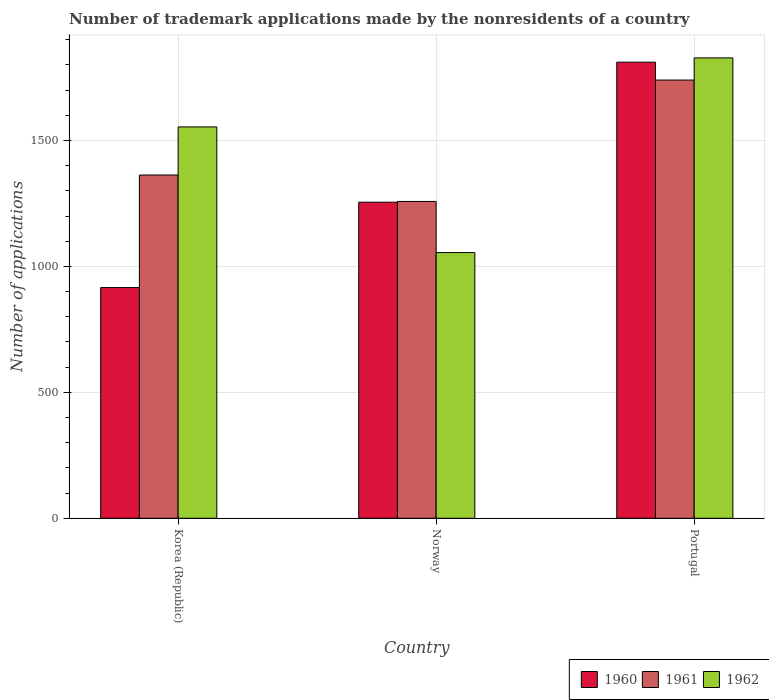How many different coloured bars are there?
Keep it short and to the point. 3. How many groups of bars are there?
Offer a terse response. 3. Are the number of bars per tick equal to the number of legend labels?
Your response must be concise. Yes. Are the number of bars on each tick of the X-axis equal?
Ensure brevity in your answer.  Yes. How many bars are there on the 2nd tick from the left?
Your answer should be very brief. 3. In how many cases, is the number of bars for a given country not equal to the number of legend labels?
Offer a very short reply. 0. What is the number of trademark applications made by the nonresidents in 1960 in Portugal?
Your answer should be very brief. 1811. Across all countries, what is the maximum number of trademark applications made by the nonresidents in 1961?
Offer a terse response. 1740. Across all countries, what is the minimum number of trademark applications made by the nonresidents in 1962?
Make the answer very short. 1055. In which country was the number of trademark applications made by the nonresidents in 1961 maximum?
Provide a succinct answer. Portugal. What is the total number of trademark applications made by the nonresidents in 1961 in the graph?
Your response must be concise. 4361. What is the difference between the number of trademark applications made by the nonresidents in 1960 in Korea (Republic) and that in Portugal?
Your answer should be very brief. -895. What is the difference between the number of trademark applications made by the nonresidents in 1961 in Norway and the number of trademark applications made by the nonresidents in 1960 in Korea (Republic)?
Provide a succinct answer. 342. What is the average number of trademark applications made by the nonresidents in 1960 per country?
Keep it short and to the point. 1327.33. What is the difference between the number of trademark applications made by the nonresidents of/in 1961 and number of trademark applications made by the nonresidents of/in 1962 in Korea (Republic)?
Give a very brief answer. -191. What is the ratio of the number of trademark applications made by the nonresidents in 1961 in Korea (Republic) to that in Norway?
Your response must be concise. 1.08. Is the difference between the number of trademark applications made by the nonresidents in 1961 in Norway and Portugal greater than the difference between the number of trademark applications made by the nonresidents in 1962 in Norway and Portugal?
Provide a short and direct response. Yes. What is the difference between the highest and the second highest number of trademark applications made by the nonresidents in 1962?
Ensure brevity in your answer.  -274. What is the difference between the highest and the lowest number of trademark applications made by the nonresidents in 1962?
Offer a very short reply. 773. Does the graph contain any zero values?
Your response must be concise. No. How are the legend labels stacked?
Provide a short and direct response. Horizontal. What is the title of the graph?
Make the answer very short. Number of trademark applications made by the nonresidents of a country. Does "1999" appear as one of the legend labels in the graph?
Provide a succinct answer. No. What is the label or title of the Y-axis?
Your answer should be compact. Number of applications. What is the Number of applications of 1960 in Korea (Republic)?
Your answer should be very brief. 916. What is the Number of applications in 1961 in Korea (Republic)?
Offer a very short reply. 1363. What is the Number of applications in 1962 in Korea (Republic)?
Provide a succinct answer. 1554. What is the Number of applications in 1960 in Norway?
Give a very brief answer. 1255. What is the Number of applications of 1961 in Norway?
Keep it short and to the point. 1258. What is the Number of applications in 1962 in Norway?
Provide a short and direct response. 1055. What is the Number of applications in 1960 in Portugal?
Your answer should be very brief. 1811. What is the Number of applications of 1961 in Portugal?
Give a very brief answer. 1740. What is the Number of applications in 1962 in Portugal?
Your response must be concise. 1828. Across all countries, what is the maximum Number of applications of 1960?
Provide a short and direct response. 1811. Across all countries, what is the maximum Number of applications in 1961?
Make the answer very short. 1740. Across all countries, what is the maximum Number of applications in 1962?
Provide a succinct answer. 1828. Across all countries, what is the minimum Number of applications of 1960?
Give a very brief answer. 916. Across all countries, what is the minimum Number of applications of 1961?
Your response must be concise. 1258. Across all countries, what is the minimum Number of applications of 1962?
Provide a succinct answer. 1055. What is the total Number of applications of 1960 in the graph?
Offer a terse response. 3982. What is the total Number of applications in 1961 in the graph?
Ensure brevity in your answer.  4361. What is the total Number of applications of 1962 in the graph?
Offer a terse response. 4437. What is the difference between the Number of applications of 1960 in Korea (Republic) and that in Norway?
Provide a succinct answer. -339. What is the difference between the Number of applications of 1961 in Korea (Republic) and that in Norway?
Give a very brief answer. 105. What is the difference between the Number of applications of 1962 in Korea (Republic) and that in Norway?
Your answer should be compact. 499. What is the difference between the Number of applications in 1960 in Korea (Republic) and that in Portugal?
Keep it short and to the point. -895. What is the difference between the Number of applications in 1961 in Korea (Republic) and that in Portugal?
Your response must be concise. -377. What is the difference between the Number of applications of 1962 in Korea (Republic) and that in Portugal?
Give a very brief answer. -274. What is the difference between the Number of applications of 1960 in Norway and that in Portugal?
Your response must be concise. -556. What is the difference between the Number of applications of 1961 in Norway and that in Portugal?
Your answer should be very brief. -482. What is the difference between the Number of applications in 1962 in Norway and that in Portugal?
Offer a very short reply. -773. What is the difference between the Number of applications of 1960 in Korea (Republic) and the Number of applications of 1961 in Norway?
Your answer should be compact. -342. What is the difference between the Number of applications of 1960 in Korea (Republic) and the Number of applications of 1962 in Norway?
Keep it short and to the point. -139. What is the difference between the Number of applications of 1961 in Korea (Republic) and the Number of applications of 1962 in Norway?
Ensure brevity in your answer.  308. What is the difference between the Number of applications in 1960 in Korea (Republic) and the Number of applications in 1961 in Portugal?
Ensure brevity in your answer.  -824. What is the difference between the Number of applications in 1960 in Korea (Republic) and the Number of applications in 1962 in Portugal?
Provide a short and direct response. -912. What is the difference between the Number of applications in 1961 in Korea (Republic) and the Number of applications in 1962 in Portugal?
Provide a succinct answer. -465. What is the difference between the Number of applications in 1960 in Norway and the Number of applications in 1961 in Portugal?
Offer a very short reply. -485. What is the difference between the Number of applications in 1960 in Norway and the Number of applications in 1962 in Portugal?
Ensure brevity in your answer.  -573. What is the difference between the Number of applications of 1961 in Norway and the Number of applications of 1962 in Portugal?
Your answer should be compact. -570. What is the average Number of applications of 1960 per country?
Give a very brief answer. 1327.33. What is the average Number of applications in 1961 per country?
Your answer should be very brief. 1453.67. What is the average Number of applications in 1962 per country?
Make the answer very short. 1479. What is the difference between the Number of applications of 1960 and Number of applications of 1961 in Korea (Republic)?
Your answer should be very brief. -447. What is the difference between the Number of applications in 1960 and Number of applications in 1962 in Korea (Republic)?
Your response must be concise. -638. What is the difference between the Number of applications in 1961 and Number of applications in 1962 in Korea (Republic)?
Keep it short and to the point. -191. What is the difference between the Number of applications of 1960 and Number of applications of 1962 in Norway?
Provide a succinct answer. 200. What is the difference between the Number of applications in 1961 and Number of applications in 1962 in Norway?
Make the answer very short. 203. What is the difference between the Number of applications of 1960 and Number of applications of 1961 in Portugal?
Offer a very short reply. 71. What is the difference between the Number of applications of 1960 and Number of applications of 1962 in Portugal?
Your answer should be compact. -17. What is the difference between the Number of applications in 1961 and Number of applications in 1962 in Portugal?
Provide a short and direct response. -88. What is the ratio of the Number of applications in 1960 in Korea (Republic) to that in Norway?
Ensure brevity in your answer.  0.73. What is the ratio of the Number of applications in 1961 in Korea (Republic) to that in Norway?
Give a very brief answer. 1.08. What is the ratio of the Number of applications in 1962 in Korea (Republic) to that in Norway?
Your answer should be compact. 1.47. What is the ratio of the Number of applications in 1960 in Korea (Republic) to that in Portugal?
Provide a succinct answer. 0.51. What is the ratio of the Number of applications in 1961 in Korea (Republic) to that in Portugal?
Provide a short and direct response. 0.78. What is the ratio of the Number of applications of 1962 in Korea (Republic) to that in Portugal?
Offer a very short reply. 0.85. What is the ratio of the Number of applications in 1960 in Norway to that in Portugal?
Offer a very short reply. 0.69. What is the ratio of the Number of applications in 1961 in Norway to that in Portugal?
Your answer should be compact. 0.72. What is the ratio of the Number of applications of 1962 in Norway to that in Portugal?
Offer a very short reply. 0.58. What is the difference between the highest and the second highest Number of applications of 1960?
Keep it short and to the point. 556. What is the difference between the highest and the second highest Number of applications of 1961?
Your answer should be very brief. 377. What is the difference between the highest and the second highest Number of applications of 1962?
Ensure brevity in your answer.  274. What is the difference between the highest and the lowest Number of applications of 1960?
Offer a very short reply. 895. What is the difference between the highest and the lowest Number of applications of 1961?
Offer a very short reply. 482. What is the difference between the highest and the lowest Number of applications of 1962?
Keep it short and to the point. 773. 